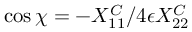Convert formula to latex. <formula><loc_0><loc_0><loc_500><loc_500>\cos \chi = - X _ { 1 1 } ^ { C } / 4 \epsilon X _ { 2 2 } ^ { C }</formula> 